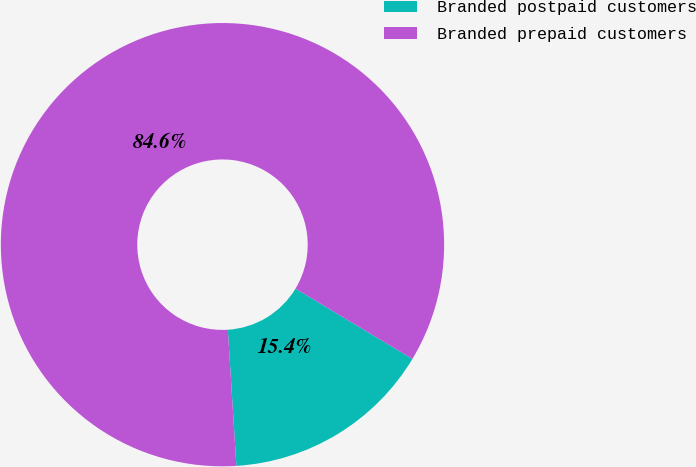Convert chart. <chart><loc_0><loc_0><loc_500><loc_500><pie_chart><fcel>Branded postpaid customers<fcel>Branded prepaid customers<nl><fcel>15.38%<fcel>84.62%<nl></chart> 